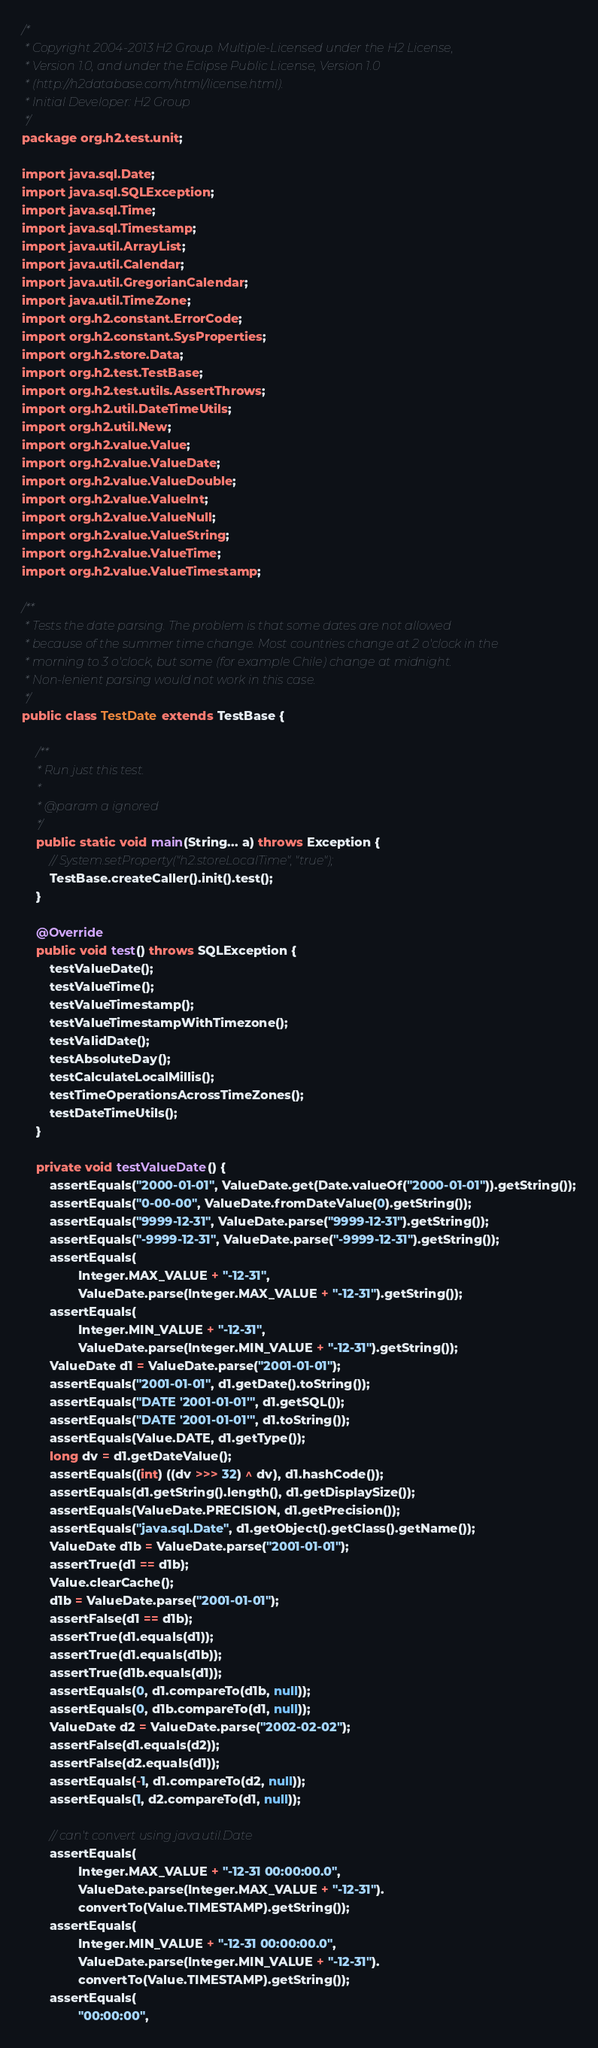Convert code to text. <code><loc_0><loc_0><loc_500><loc_500><_Java_>/*
 * Copyright 2004-2013 H2 Group. Multiple-Licensed under the H2 License,
 * Version 1.0, and under the Eclipse Public License, Version 1.0
 * (http://h2database.com/html/license.html).
 * Initial Developer: H2 Group
 */
package org.h2.test.unit;

import java.sql.Date;
import java.sql.SQLException;
import java.sql.Time;
import java.sql.Timestamp;
import java.util.ArrayList;
import java.util.Calendar;
import java.util.GregorianCalendar;
import java.util.TimeZone;
import org.h2.constant.ErrorCode;
import org.h2.constant.SysProperties;
import org.h2.store.Data;
import org.h2.test.TestBase;
import org.h2.test.utils.AssertThrows;
import org.h2.util.DateTimeUtils;
import org.h2.util.New;
import org.h2.value.Value;
import org.h2.value.ValueDate;
import org.h2.value.ValueDouble;
import org.h2.value.ValueInt;
import org.h2.value.ValueNull;
import org.h2.value.ValueString;
import org.h2.value.ValueTime;
import org.h2.value.ValueTimestamp;

/**
 * Tests the date parsing. The problem is that some dates are not allowed
 * because of the summer time change. Most countries change at 2 o'clock in the
 * morning to 3 o'clock, but some (for example Chile) change at midnight.
 * Non-lenient parsing would not work in this case.
 */
public class TestDate extends TestBase {

    /**
     * Run just this test.
     *
     * @param a ignored
     */
    public static void main(String... a) throws Exception {
        // System.setProperty("h2.storeLocalTime", "true");
        TestBase.createCaller().init().test();
    }

    @Override
    public void test() throws SQLException {
        testValueDate();
        testValueTime();
        testValueTimestamp();
        testValueTimestampWithTimezone();
        testValidDate();
        testAbsoluteDay();
        testCalculateLocalMillis();
        testTimeOperationsAcrossTimeZones();
        testDateTimeUtils();
    }

    private void testValueDate() {
        assertEquals("2000-01-01", ValueDate.get(Date.valueOf("2000-01-01")).getString());
        assertEquals("0-00-00", ValueDate.fromDateValue(0).getString());
        assertEquals("9999-12-31", ValueDate.parse("9999-12-31").getString());
        assertEquals("-9999-12-31", ValueDate.parse("-9999-12-31").getString());
        assertEquals(
                Integer.MAX_VALUE + "-12-31",
                ValueDate.parse(Integer.MAX_VALUE + "-12-31").getString());
        assertEquals(
                Integer.MIN_VALUE + "-12-31",
                ValueDate.parse(Integer.MIN_VALUE + "-12-31").getString());
        ValueDate d1 = ValueDate.parse("2001-01-01");
        assertEquals("2001-01-01", d1.getDate().toString());
        assertEquals("DATE '2001-01-01'", d1.getSQL());
        assertEquals("DATE '2001-01-01'", d1.toString());
        assertEquals(Value.DATE, d1.getType());
        long dv = d1.getDateValue();
        assertEquals((int) ((dv >>> 32) ^ dv), d1.hashCode());
        assertEquals(d1.getString().length(), d1.getDisplaySize());
        assertEquals(ValueDate.PRECISION, d1.getPrecision());
        assertEquals("java.sql.Date", d1.getObject().getClass().getName());
        ValueDate d1b = ValueDate.parse("2001-01-01");
        assertTrue(d1 == d1b);
        Value.clearCache();
        d1b = ValueDate.parse("2001-01-01");
        assertFalse(d1 == d1b);
        assertTrue(d1.equals(d1));
        assertTrue(d1.equals(d1b));
        assertTrue(d1b.equals(d1));
        assertEquals(0, d1.compareTo(d1b, null));
        assertEquals(0, d1b.compareTo(d1, null));
        ValueDate d2 = ValueDate.parse("2002-02-02");
        assertFalse(d1.equals(d2));
        assertFalse(d2.equals(d1));
        assertEquals(-1, d1.compareTo(d2, null));
        assertEquals(1, d2.compareTo(d1, null));

        // can't convert using java.util.Date
        assertEquals(
                Integer.MAX_VALUE + "-12-31 00:00:00.0",
                ValueDate.parse(Integer.MAX_VALUE + "-12-31").
                convertTo(Value.TIMESTAMP).getString());
        assertEquals(
                Integer.MIN_VALUE + "-12-31 00:00:00.0",
                ValueDate.parse(Integer.MIN_VALUE + "-12-31").
                convertTo(Value.TIMESTAMP).getString());
        assertEquals(
                "00:00:00",</code> 